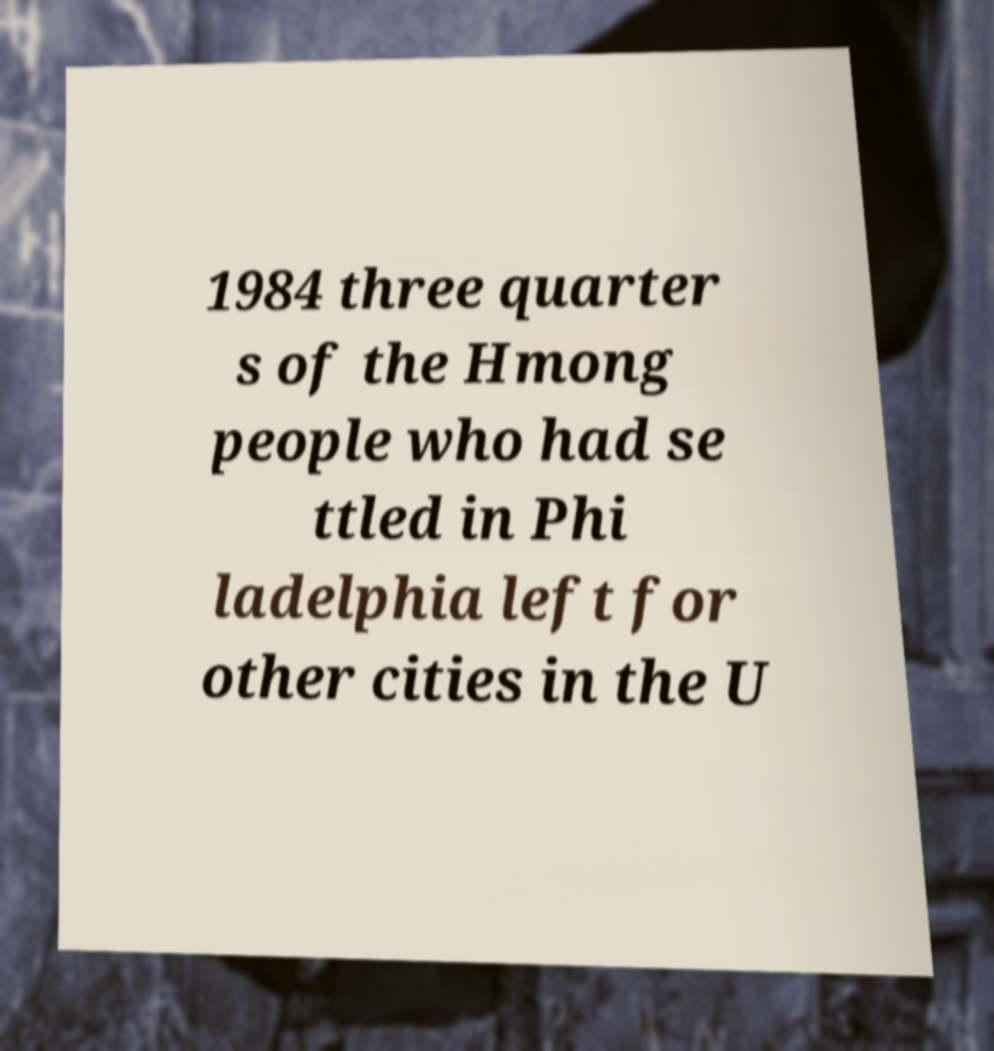Please read and relay the text visible in this image. What does it say? 1984 three quarter s of the Hmong people who had se ttled in Phi ladelphia left for other cities in the U 